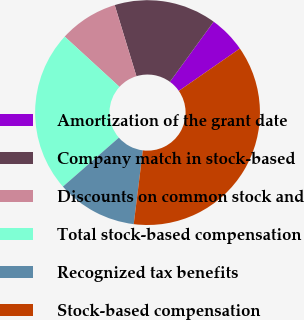<chart> <loc_0><loc_0><loc_500><loc_500><pie_chart><fcel>Amortization of the grant date<fcel>Company match in stock-based<fcel>Discounts on common stock and<fcel>Total stock-based compensation<fcel>Recognized tax benefits<fcel>Stock-based compensation<nl><fcel>5.34%<fcel>14.72%<fcel>8.47%<fcel>23.25%<fcel>11.6%<fcel>36.61%<nl></chart> 